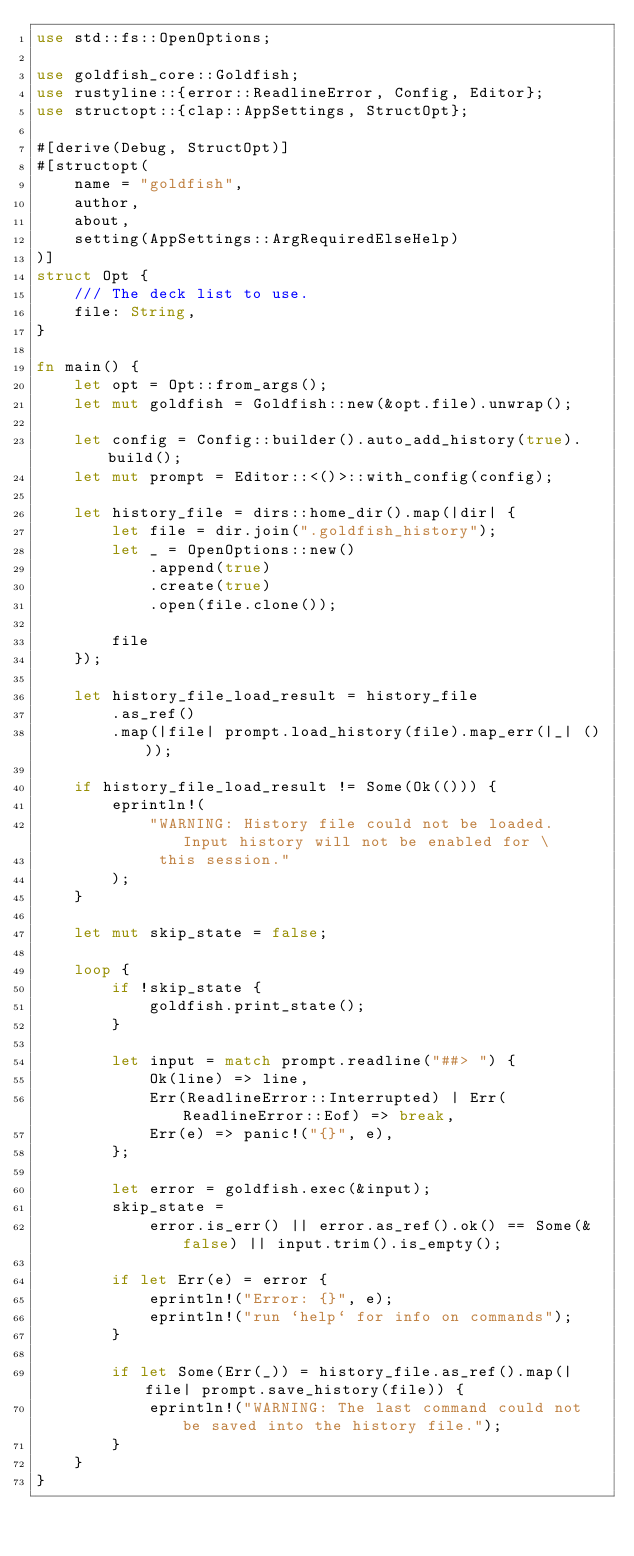<code> <loc_0><loc_0><loc_500><loc_500><_Rust_>use std::fs::OpenOptions;

use goldfish_core::Goldfish;
use rustyline::{error::ReadlineError, Config, Editor};
use structopt::{clap::AppSettings, StructOpt};

#[derive(Debug, StructOpt)]
#[structopt(
    name = "goldfish",
    author,
    about,
    setting(AppSettings::ArgRequiredElseHelp)
)]
struct Opt {
    /// The deck list to use.
    file: String,
}

fn main() {
    let opt = Opt::from_args();
    let mut goldfish = Goldfish::new(&opt.file).unwrap();

    let config = Config::builder().auto_add_history(true).build();
    let mut prompt = Editor::<()>::with_config(config);

    let history_file = dirs::home_dir().map(|dir| {
        let file = dir.join(".goldfish_history");
        let _ = OpenOptions::new()
            .append(true)
            .create(true)
            .open(file.clone());

        file
    });

    let history_file_load_result = history_file
        .as_ref()
        .map(|file| prompt.load_history(file).map_err(|_| ()));

    if history_file_load_result != Some(Ok(())) {
        eprintln!(
            "WARNING: History file could not be loaded. Input history will not be enabled for \
             this session."
        );
    }

    let mut skip_state = false;

    loop {
        if !skip_state {
            goldfish.print_state();
        }

        let input = match prompt.readline("##> ") {
            Ok(line) => line,
            Err(ReadlineError::Interrupted) | Err(ReadlineError::Eof) => break,
            Err(e) => panic!("{}", e),
        };

        let error = goldfish.exec(&input);
        skip_state =
            error.is_err() || error.as_ref().ok() == Some(&false) || input.trim().is_empty();

        if let Err(e) = error {
            eprintln!("Error: {}", e);
            eprintln!("run `help` for info on commands");
        }

        if let Some(Err(_)) = history_file.as_ref().map(|file| prompt.save_history(file)) {
            eprintln!("WARNING: The last command could not be saved into the history file.");
        }
    }
}
</code> 